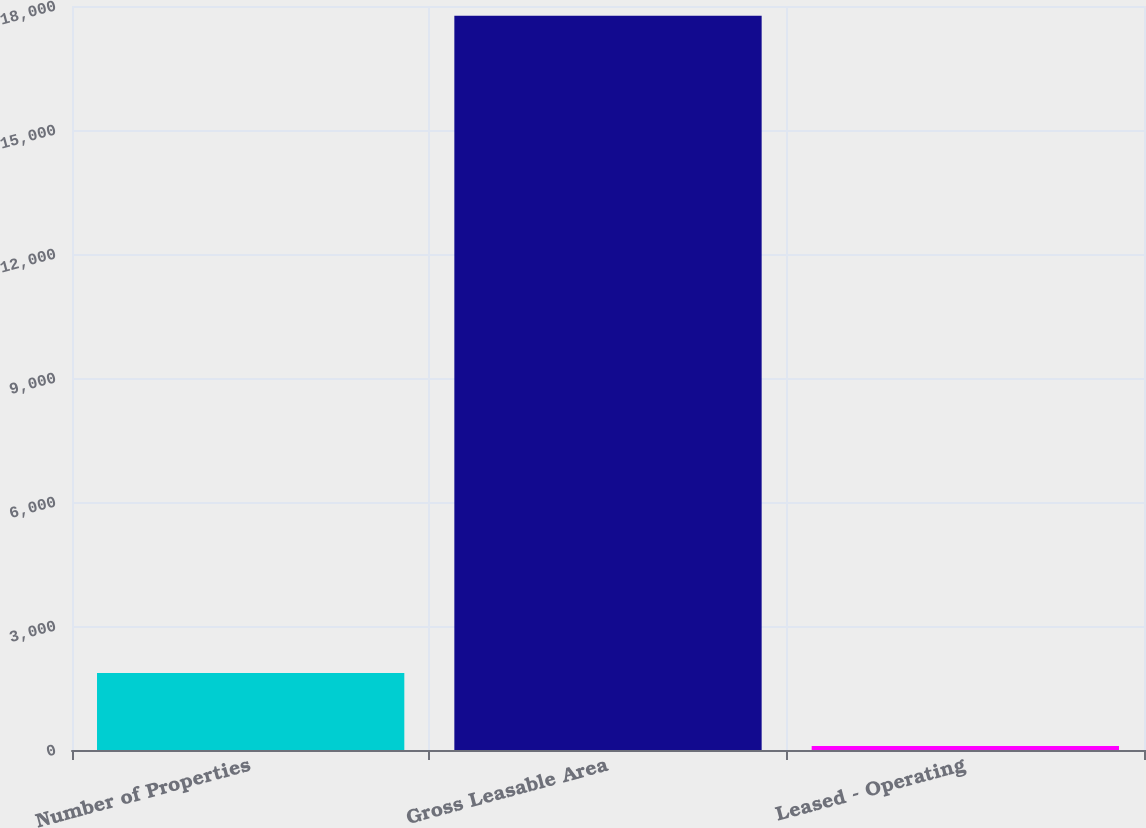Convert chart. <chart><loc_0><loc_0><loc_500><loc_500><bar_chart><fcel>Number of Properties<fcel>Gross Leasable Area<fcel>Leased - Operating<nl><fcel>1861.88<fcel>17762<fcel>95.2<nl></chart> 